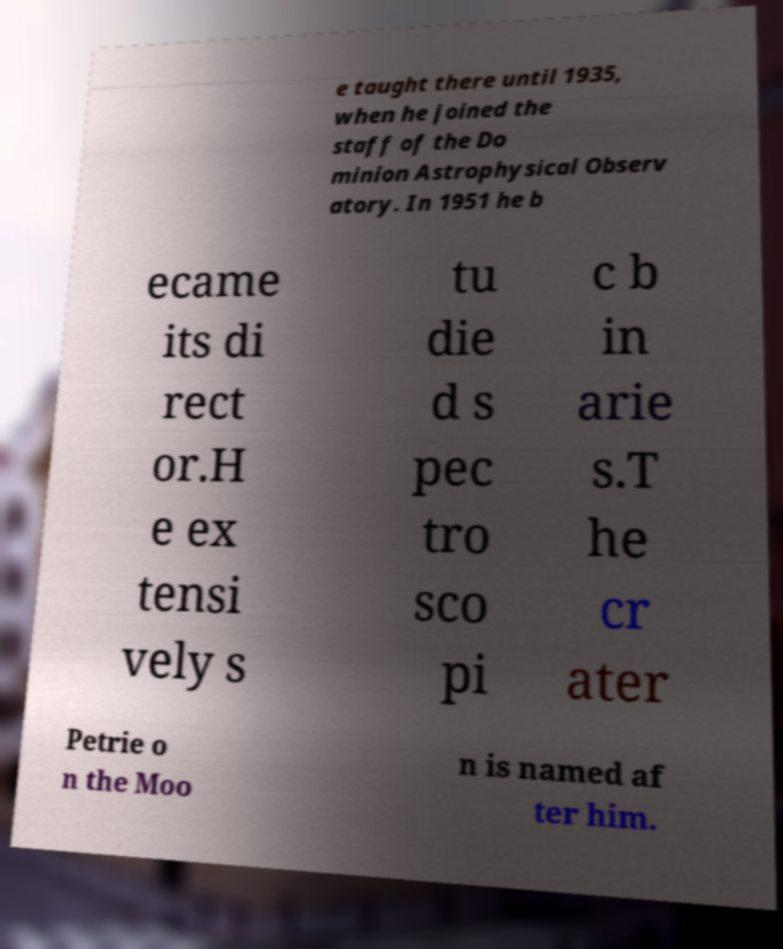Can you read and provide the text displayed in the image?This photo seems to have some interesting text. Can you extract and type it out for me? e taught there until 1935, when he joined the staff of the Do minion Astrophysical Observ atory. In 1951 he b ecame its di rect or.H e ex tensi vely s tu die d s pec tro sco pi c b in arie s.T he cr ater Petrie o n the Moo n is named af ter him. 